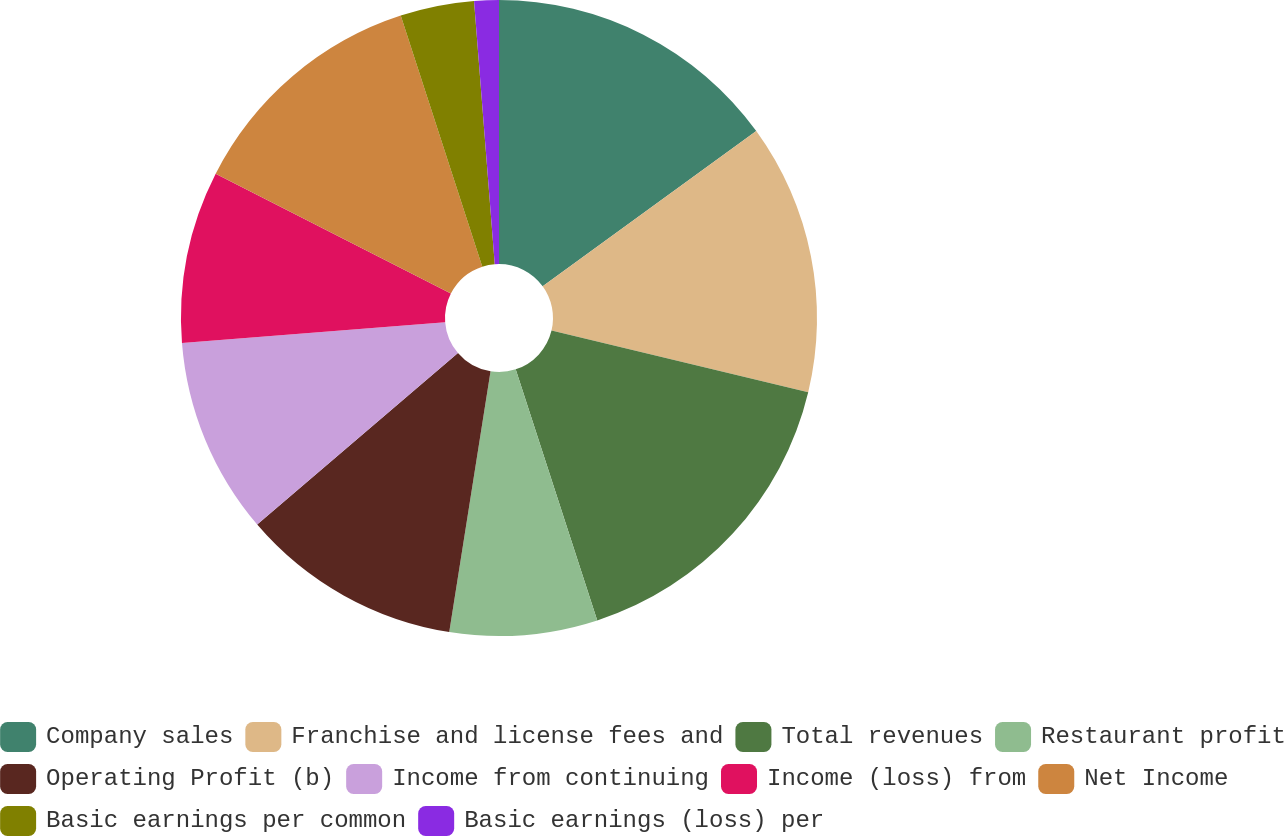Convert chart. <chart><loc_0><loc_0><loc_500><loc_500><pie_chart><fcel>Company sales<fcel>Franchise and license fees and<fcel>Total revenues<fcel>Restaurant profit<fcel>Operating Profit (b)<fcel>Income from continuing<fcel>Income (loss) from<fcel>Net Income<fcel>Basic earnings per common<fcel>Basic earnings (loss) per<nl><fcel>15.0%<fcel>13.75%<fcel>16.25%<fcel>7.5%<fcel>11.25%<fcel>10.0%<fcel>8.75%<fcel>12.5%<fcel>3.75%<fcel>1.25%<nl></chart> 